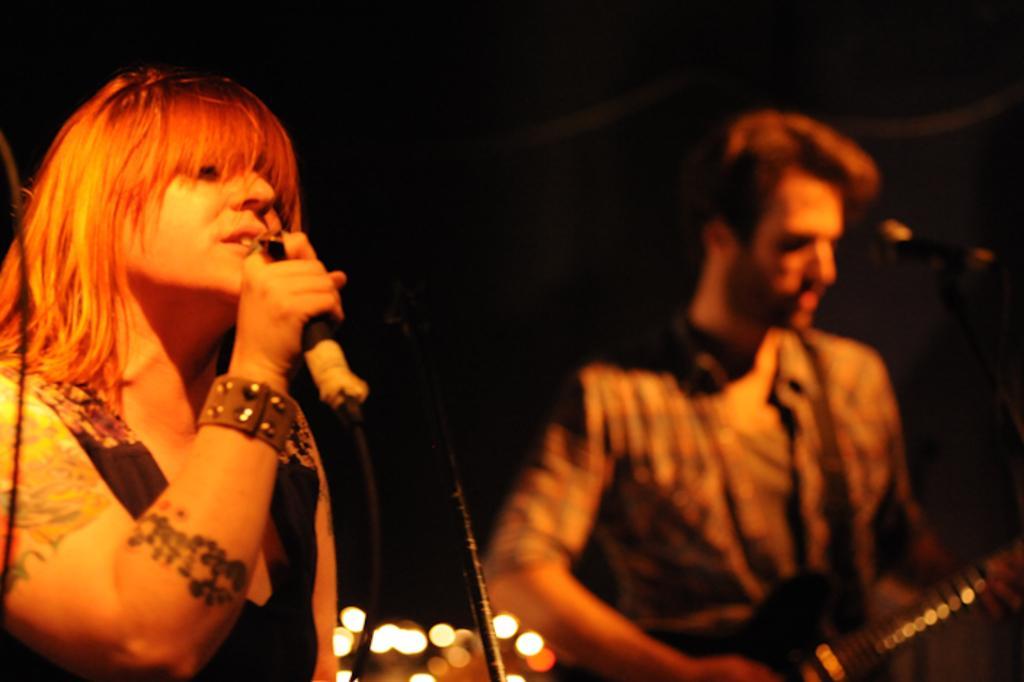Please provide a concise description of this image. On the left side of the image we can see girl singing in the mic. On the right side of the image we can see person holding a guitar. 